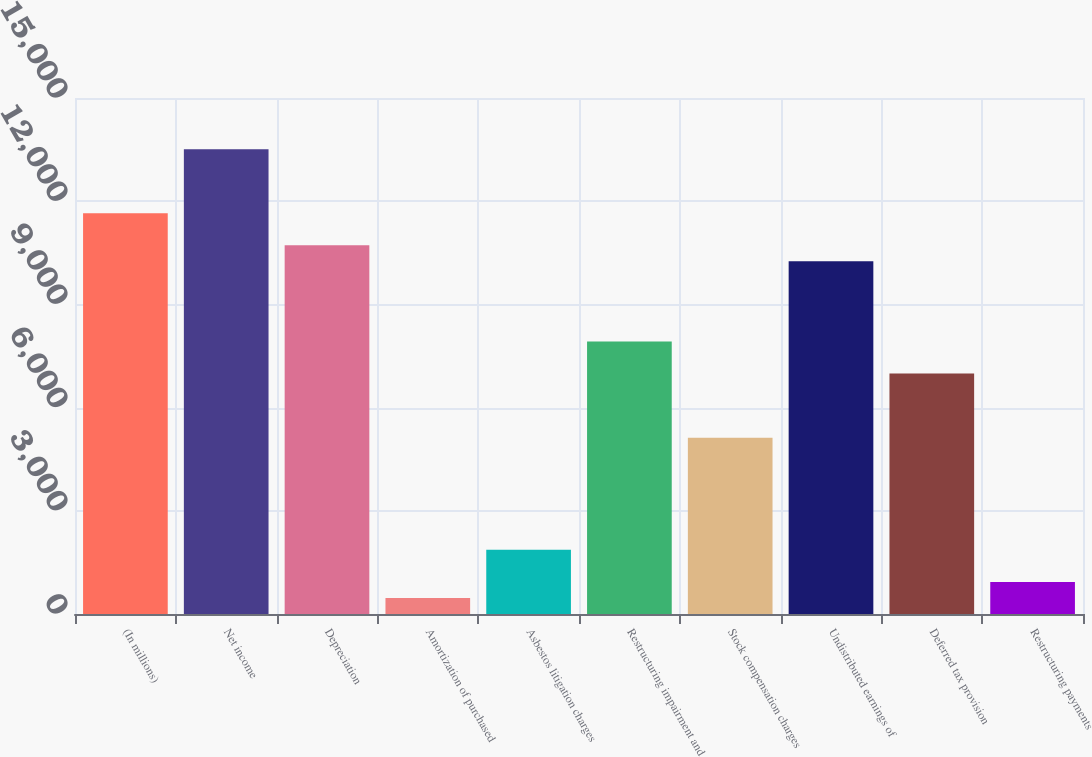Convert chart. <chart><loc_0><loc_0><loc_500><loc_500><bar_chart><fcel>(In millions)<fcel>Net income<fcel>Depreciation<fcel>Amortization of purchased<fcel>Asbestos litigation charges<fcel>Restructuring impairment and<fcel>Stock compensation charges<fcel>Undistributed earnings of<fcel>Deferred tax provision<fcel>Restructuring payments<nl><fcel>11649.5<fcel>13513.1<fcel>10717.7<fcel>467.9<fcel>1865.6<fcel>7922.3<fcel>5126.9<fcel>10251.8<fcel>6990.5<fcel>933.8<nl></chart> 